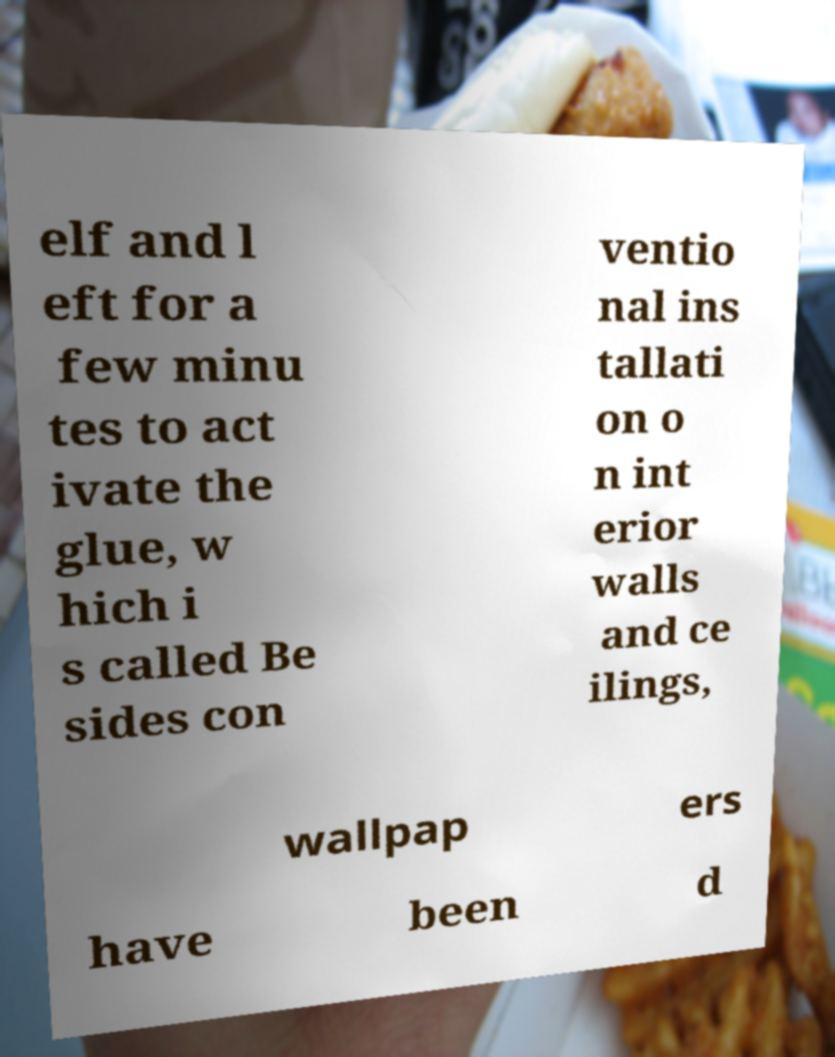Could you extract and type out the text from this image? elf and l eft for a few minu tes to act ivate the glue, w hich i s called Be sides con ventio nal ins tallati on o n int erior walls and ce ilings, wallpap ers have been d 